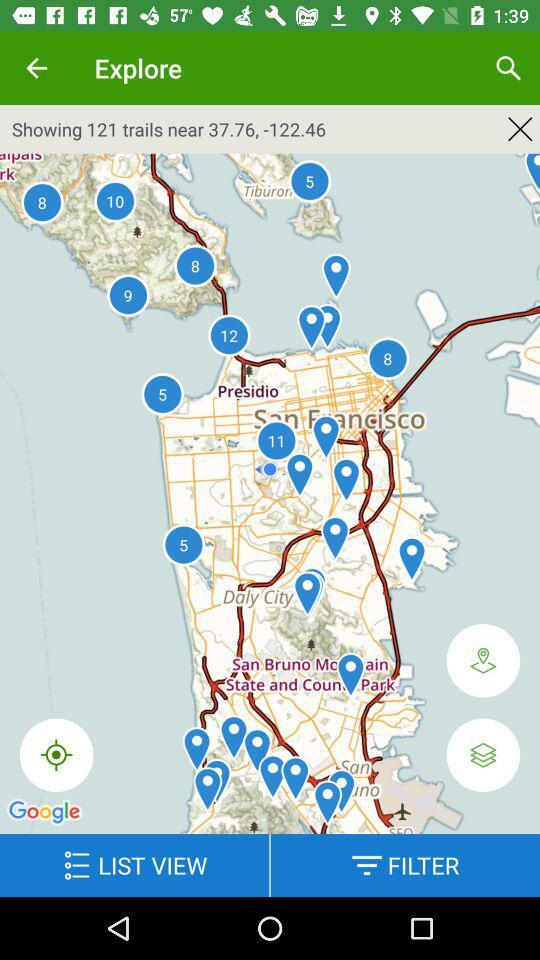How many trails are shown near 37.76, -122.46? The trails are 121. 